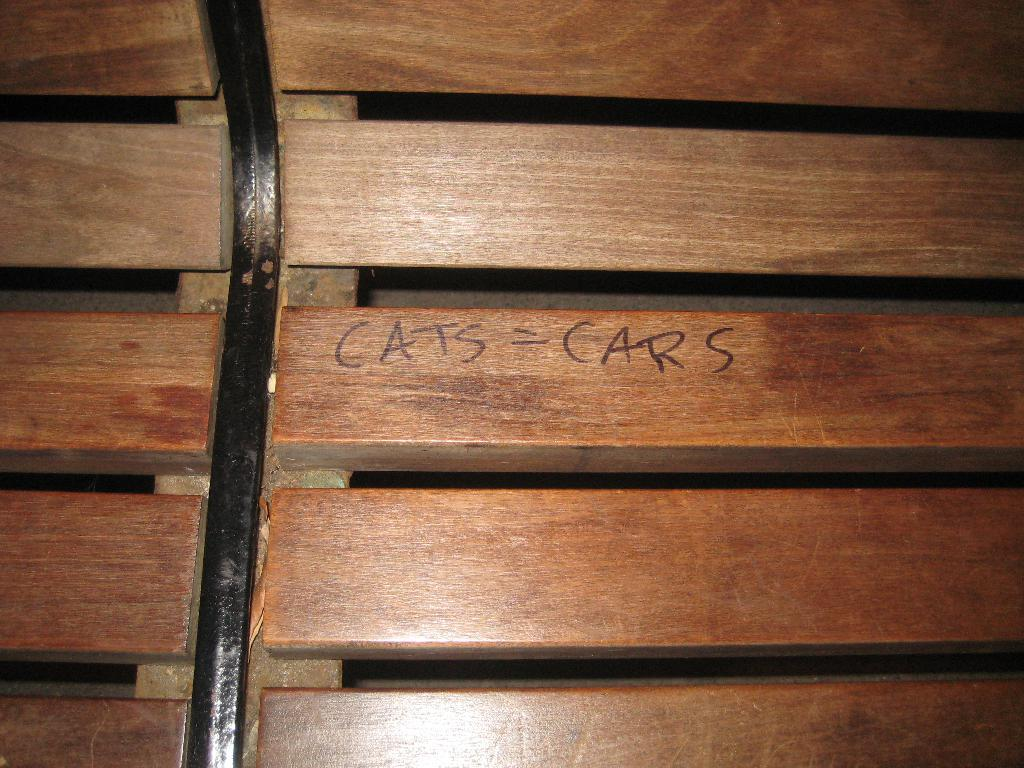What type of furniture is present in the image? There is a bench in the image. What material is used to make the objects on the bench? The objects on the bench are made of wood. Can you describe the text or message in the center of the image? There are words written in the center of the image. What type of arithmetic problem is being solved on the bench? There is no arithmetic problem present in the image; it only features a bench with wooden objects and words written in the center. 